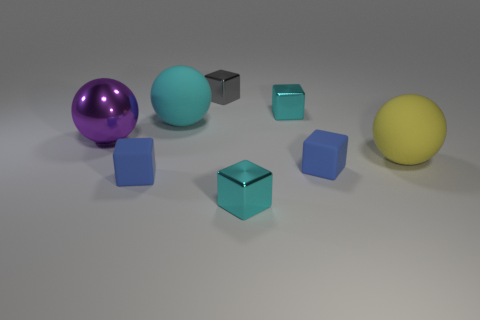Subtract 2 blocks. How many blocks are left? 3 Subtract all gray blocks. How many blocks are left? 4 Subtract all tiny gray metallic blocks. How many blocks are left? 4 Subtract all purple blocks. Subtract all blue cylinders. How many blocks are left? 5 Add 2 large purple matte cylinders. How many objects exist? 10 Subtract all spheres. How many objects are left? 5 Subtract all tiny cyan matte cylinders. Subtract all cyan rubber objects. How many objects are left? 7 Add 4 small blue blocks. How many small blue blocks are left? 6 Add 6 cyan shiny objects. How many cyan shiny objects exist? 8 Subtract 1 cyan cubes. How many objects are left? 7 